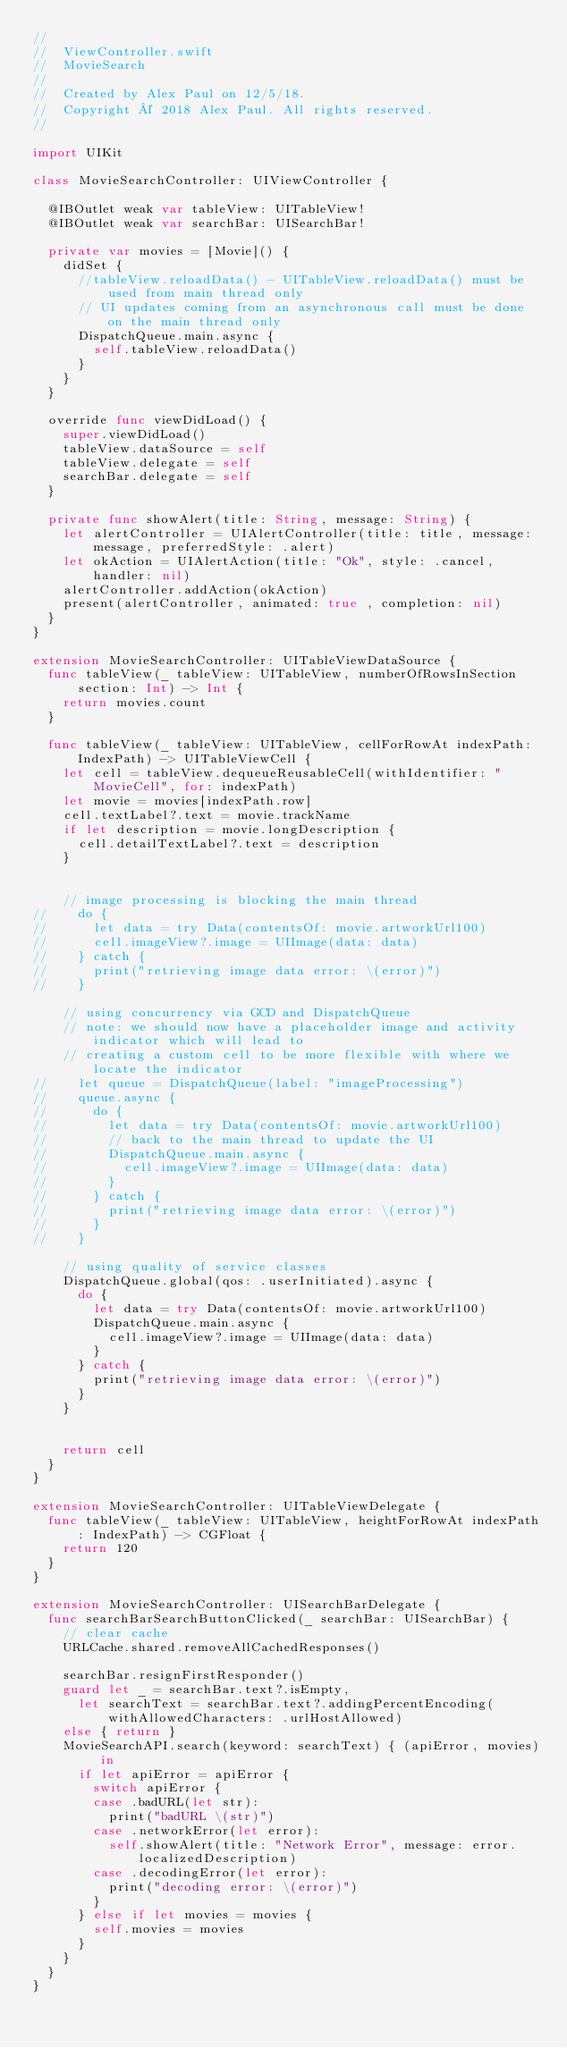<code> <loc_0><loc_0><loc_500><loc_500><_Swift_>//
//  ViewController.swift
//  MovieSearch
//
//  Created by Alex Paul on 12/5/18.
//  Copyright © 2018 Alex Paul. All rights reserved.
//

import UIKit

class MovieSearchController: UIViewController {
  
  @IBOutlet weak var tableView: UITableView!
  @IBOutlet weak var searchBar: UISearchBar!
  
  private var movies = [Movie]() {
    didSet {
      //tableView.reloadData() - UITableView.reloadData() must be used from main thread only
      // UI updates coming from an asynchronous call must be done on the main thread only
      DispatchQueue.main.async {
        self.tableView.reloadData()
      }
    }
  }

  override func viewDidLoad() {
    super.viewDidLoad()
    tableView.dataSource = self
    tableView.delegate = self
    searchBar.delegate = self
  }
  
  private func showAlert(title: String, message: String) {
    let alertController = UIAlertController(title: title, message: message, preferredStyle: .alert)
    let okAction = UIAlertAction(title: "Ok", style: .cancel, handler: nil)
    alertController.addAction(okAction)
    present(alertController, animated: true , completion: nil)
  }
}

extension MovieSearchController: UITableViewDataSource {
  func tableView(_ tableView: UITableView, numberOfRowsInSection section: Int) -> Int {
    return movies.count
  }
  
  func tableView(_ tableView: UITableView, cellForRowAt indexPath: IndexPath) -> UITableViewCell {
    let cell = tableView.dequeueReusableCell(withIdentifier: "MovieCell", for: indexPath)
    let movie = movies[indexPath.row]
    cell.textLabel?.text = movie.trackName
    if let description = movie.longDescription {
      cell.detailTextLabel?.text = description
    }
    
    
    // image processing is blocking the main thread
//    do {
//      let data = try Data(contentsOf: movie.artworkUrl100)
//      cell.imageView?.image = UIImage(data: data)
//    } catch {
//      print("retrieving image data error: \(error)")
//    }
    
    // using concurrency via GCD and DispatchQueue
    // note: we should now have a placeholder image and activity indicator which will lead to
    // creating a custom cell to be more flexible with where we locate the indicator
//    let queue = DispatchQueue(label: "imageProcessing")
//    queue.async {
//      do {
//        let data = try Data(contentsOf: movie.artworkUrl100)
//        // back to the main thread to update the UI
//        DispatchQueue.main.async {
//          cell.imageView?.image = UIImage(data: data)
//        }
//      } catch {
//        print("retrieving image data error: \(error)")
//      }
//    }
    
    // using quality of service classes
    DispatchQueue.global(qos: .userInitiated).async {
      do {
        let data = try Data(contentsOf: movie.artworkUrl100)
        DispatchQueue.main.async {
          cell.imageView?.image = UIImage(data: data)
        }
      } catch {
        print("retrieving image data error: \(error)")
      }
    }
    
    
    return cell
  }
}

extension MovieSearchController: UITableViewDelegate {
  func tableView(_ tableView: UITableView, heightForRowAt indexPath: IndexPath) -> CGFloat {
    return 120
  }
}

extension MovieSearchController: UISearchBarDelegate {
  func searchBarSearchButtonClicked(_ searchBar: UISearchBar) {
    // clear cache
    URLCache.shared.removeAllCachedResponses()
    
    searchBar.resignFirstResponder()
    guard let _ = searchBar.text?.isEmpty,
      let searchText = searchBar.text?.addingPercentEncoding(withAllowedCharacters: .urlHostAllowed)
    else { return }
    MovieSearchAPI.search(keyword: searchText) { (apiError, movies) in
      if let apiError = apiError {
        switch apiError {
        case .badURL(let str):
          print("badURL \(str)")
        case .networkError(let error):
          self.showAlert(title: "Network Error", message: error.localizedDescription)
        case .decodingError(let error):
          print("decoding error: \(error)")
        }
      } else if let movies = movies {
        self.movies = movies
      }
    }
  }
}

</code> 